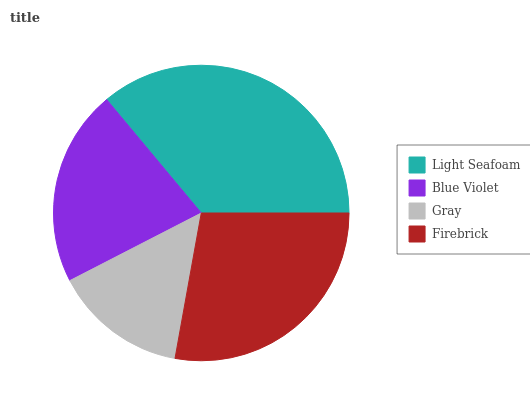Is Gray the minimum?
Answer yes or no. Yes. Is Light Seafoam the maximum?
Answer yes or no. Yes. Is Blue Violet the minimum?
Answer yes or no. No. Is Blue Violet the maximum?
Answer yes or no. No. Is Light Seafoam greater than Blue Violet?
Answer yes or no. Yes. Is Blue Violet less than Light Seafoam?
Answer yes or no. Yes. Is Blue Violet greater than Light Seafoam?
Answer yes or no. No. Is Light Seafoam less than Blue Violet?
Answer yes or no. No. Is Firebrick the high median?
Answer yes or no. Yes. Is Blue Violet the low median?
Answer yes or no. Yes. Is Gray the high median?
Answer yes or no. No. Is Firebrick the low median?
Answer yes or no. No. 